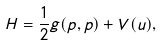Convert formula to latex. <formula><loc_0><loc_0><loc_500><loc_500>H = \frac { 1 } { 2 } g ( p , p ) + V ( u ) ,</formula> 